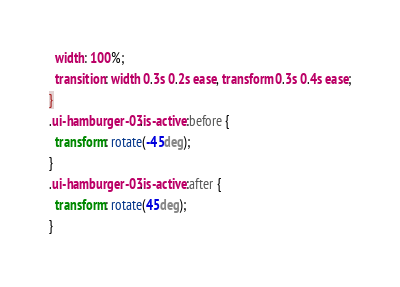Convert code to text. <code><loc_0><loc_0><loc_500><loc_500><_CSS_>  width: 100%;
  transition: width 0.3s 0.2s ease, transform 0.3s 0.4s ease;
}
.ui-hamburger-03.is-active:before {
  transform: rotate(-45deg);
}
.ui-hamburger-03.is-active:after {
  transform: rotate(45deg);
}

</code> 